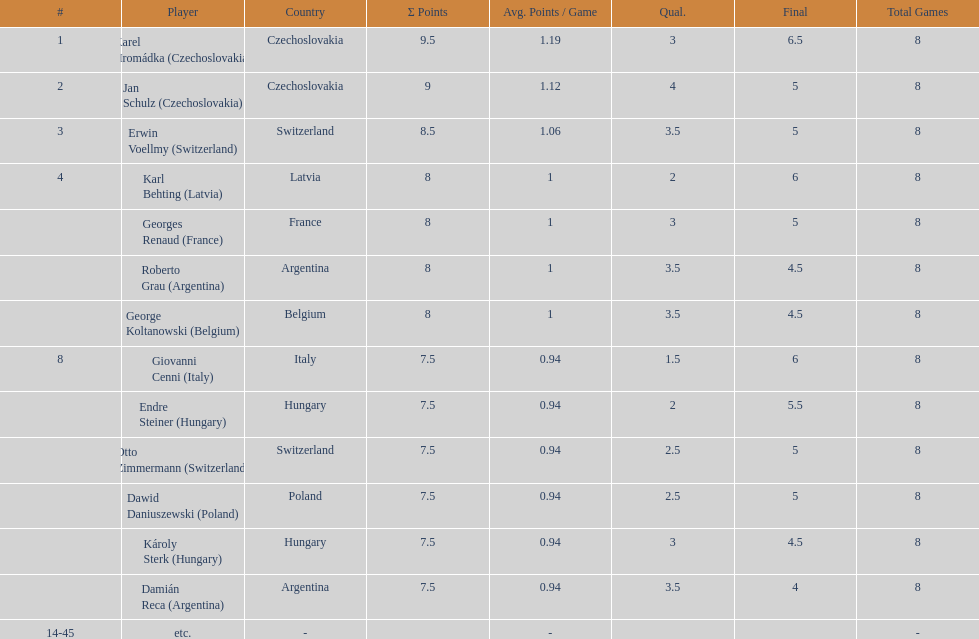How many players had a 8 points? 4. 